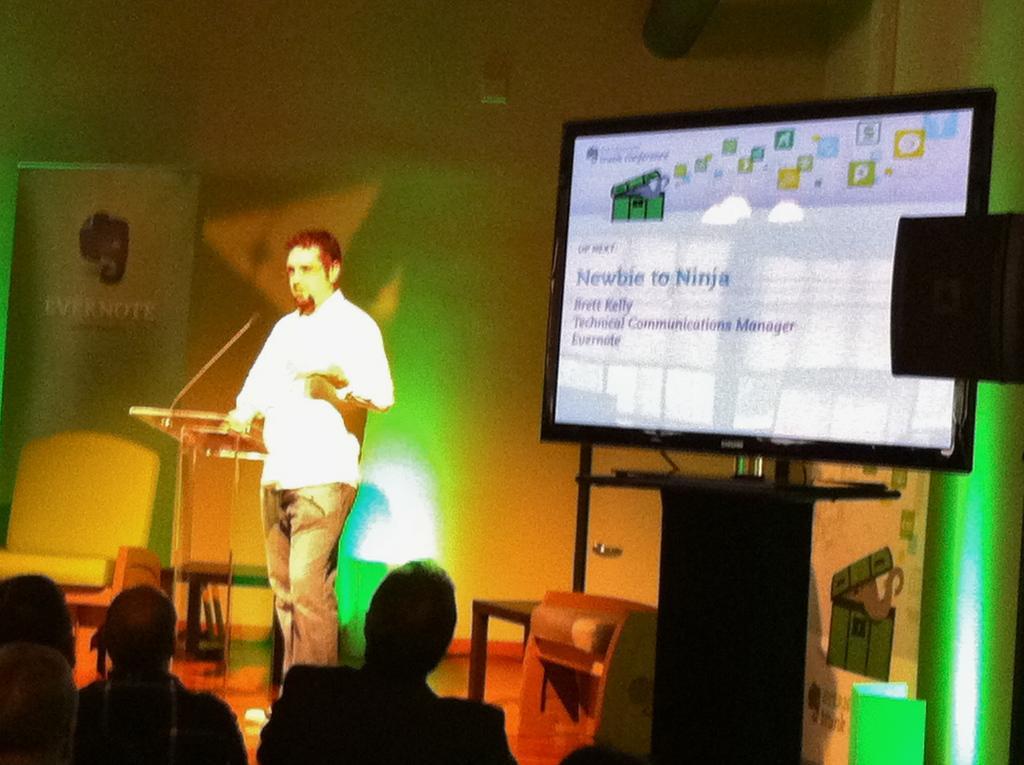Please provide a concise description of this image. On the left side of this image there is a man standing in front of the podium. At the bottom there are few people facing towards the back side. On the right side there is a monitor which is placed on a table. On the screen, I can see some text. In the background there is a wall and a banner. 